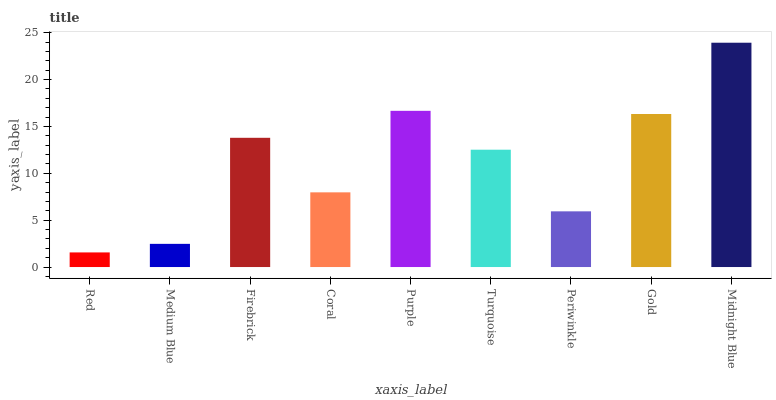Is Medium Blue the minimum?
Answer yes or no. No. Is Medium Blue the maximum?
Answer yes or no. No. Is Medium Blue greater than Red?
Answer yes or no. Yes. Is Red less than Medium Blue?
Answer yes or no. Yes. Is Red greater than Medium Blue?
Answer yes or no. No. Is Medium Blue less than Red?
Answer yes or no. No. Is Turquoise the high median?
Answer yes or no. Yes. Is Turquoise the low median?
Answer yes or no. Yes. Is Firebrick the high median?
Answer yes or no. No. Is Red the low median?
Answer yes or no. No. 